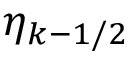Convert formula to latex. <formula><loc_0><loc_0><loc_500><loc_500>\eta _ { k - 1 / 2 }</formula> 